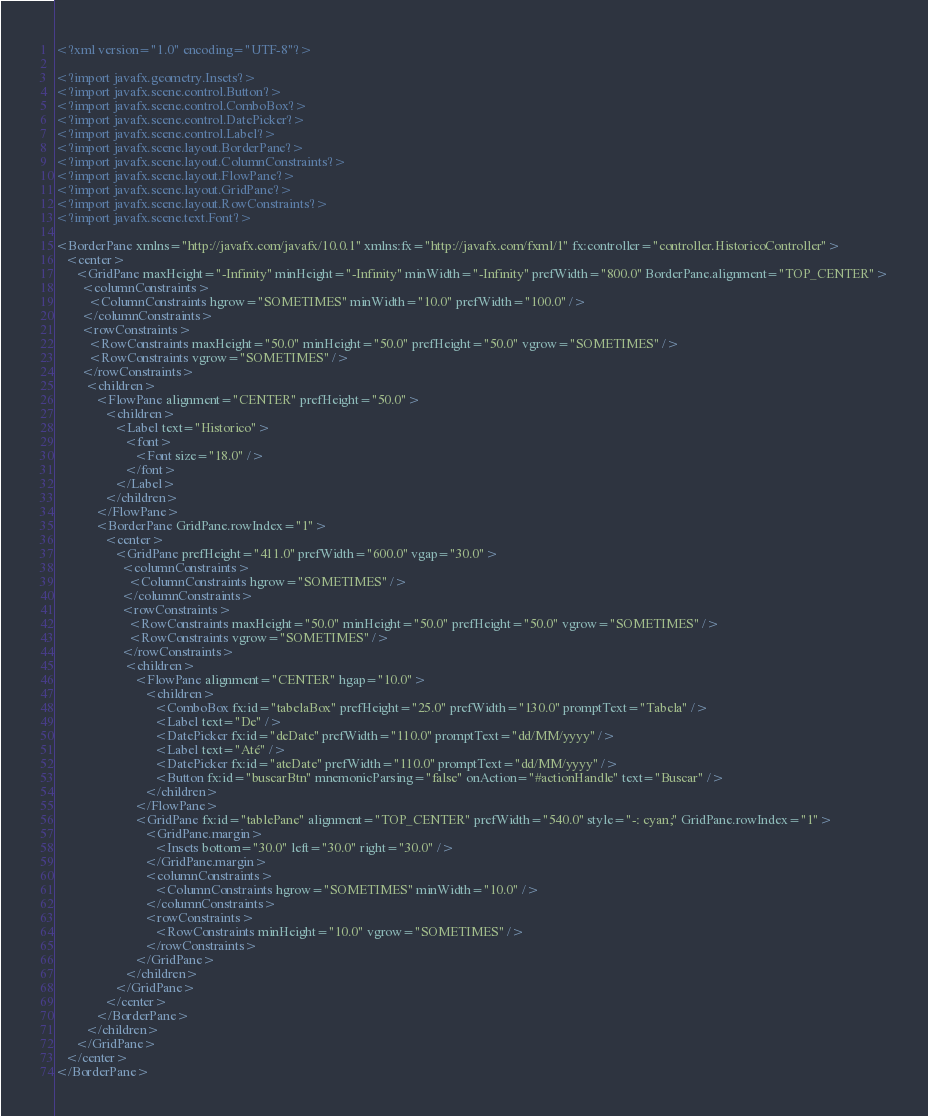<code> <loc_0><loc_0><loc_500><loc_500><_XML_><?xml version="1.0" encoding="UTF-8"?>

<?import javafx.geometry.Insets?>
<?import javafx.scene.control.Button?>
<?import javafx.scene.control.ComboBox?>
<?import javafx.scene.control.DatePicker?>
<?import javafx.scene.control.Label?>
<?import javafx.scene.layout.BorderPane?>
<?import javafx.scene.layout.ColumnConstraints?>
<?import javafx.scene.layout.FlowPane?>
<?import javafx.scene.layout.GridPane?>
<?import javafx.scene.layout.RowConstraints?>
<?import javafx.scene.text.Font?>

<BorderPane xmlns="http://javafx.com/javafx/10.0.1" xmlns:fx="http://javafx.com/fxml/1" fx:controller="controller.HistoricoController">
   <center>
      <GridPane maxHeight="-Infinity" minHeight="-Infinity" minWidth="-Infinity" prefWidth="800.0" BorderPane.alignment="TOP_CENTER">
        <columnConstraints>
          <ColumnConstraints hgrow="SOMETIMES" minWidth="10.0" prefWidth="100.0" />
        </columnConstraints>
        <rowConstraints>
          <RowConstraints maxHeight="50.0" minHeight="50.0" prefHeight="50.0" vgrow="SOMETIMES" />
          <RowConstraints vgrow="SOMETIMES" />
        </rowConstraints>
         <children>
            <FlowPane alignment="CENTER" prefHeight="50.0">
               <children>
                  <Label text="Historico">
                     <font>
                        <Font size="18.0" />
                     </font>
                  </Label>
               </children>
            </FlowPane>
            <BorderPane GridPane.rowIndex="1">
               <center>
                  <GridPane prefHeight="411.0" prefWidth="600.0" vgap="30.0">
                    <columnConstraints>
                      <ColumnConstraints hgrow="SOMETIMES" />
                    </columnConstraints>
                    <rowConstraints>
                      <RowConstraints maxHeight="50.0" minHeight="50.0" prefHeight="50.0" vgrow="SOMETIMES" />
                      <RowConstraints vgrow="SOMETIMES" />
                    </rowConstraints>
                     <children>
                        <FlowPane alignment="CENTER" hgap="10.0">
                           <children>
                              <ComboBox fx:id="tabelaBox" prefHeight="25.0" prefWidth="130.0" promptText="Tabela" />
                              <Label text="De" />
                              <DatePicker fx:id="deDate" prefWidth="110.0" promptText="dd/MM/yyyy" />
                              <Label text="Até" />
                              <DatePicker fx:id="ateDate" prefWidth="110.0" promptText="dd/MM/yyyy" />
                              <Button fx:id="buscarBtn" mnemonicParsing="false" onAction="#actionHandle" text="Buscar" />
                           </children>
                        </FlowPane>
                        <GridPane fx:id="tablePane" alignment="TOP_CENTER" prefWidth="540.0" style="-: cyan;" GridPane.rowIndex="1">
                           <GridPane.margin>
                              <Insets bottom="30.0" left="30.0" right="30.0" />
                           </GridPane.margin>
                           <columnConstraints>
                              <ColumnConstraints hgrow="SOMETIMES" minWidth="10.0" />
                           </columnConstraints>
                           <rowConstraints>
                              <RowConstraints minHeight="10.0" vgrow="SOMETIMES" />
                           </rowConstraints>
                        </GridPane>
                     </children>
                  </GridPane>
               </center>
            </BorderPane>
         </children>
      </GridPane>
   </center>
</BorderPane>
</code> 